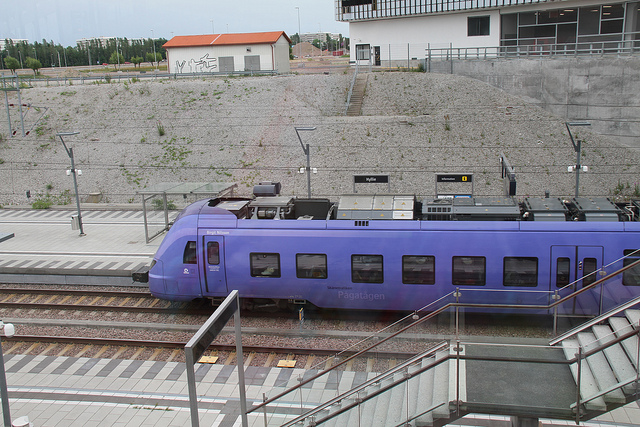Please identify all text content in this image. 0 